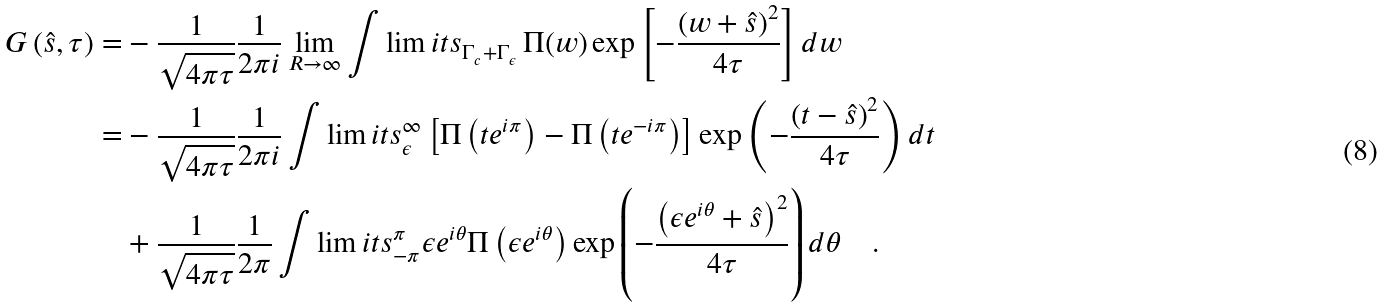Convert formula to latex. <formula><loc_0><loc_0><loc_500><loc_500>G \left ( \hat { s } , \tau \right ) = & - \frac { 1 } { \sqrt { 4 \pi \tau } } \frac { 1 } { 2 \pi i } \lim _ { R \to \infty } \int \lim i t s _ { \Gamma _ { c } + \Gamma _ { \epsilon } } \, \Pi ( w ) \exp { \left [ - \frac { \left ( w + \hat { s } \right ) ^ { 2 } } { 4 \tau } \right ] } \, d w \\ = & - \frac { 1 } { \sqrt { 4 \pi \tau } } \frac { 1 } { 2 \pi i } \int \lim i t s _ { \epsilon } ^ { \infty } \left [ \Pi \left ( t e ^ { i \pi } \right ) - \Pi \left ( t e ^ { - i \pi } \right ) \right ] \exp { \left ( - \frac { \left ( t - \hat { s } \right ) ^ { 2 } } { 4 \tau } \right ) } \, d t \\ & + \frac { 1 } { \sqrt { 4 \pi \tau } } \frac { 1 } { 2 \pi } \int \lim i t s _ { - \pi } ^ { \pi } \epsilon e ^ { i \theta } \Pi \left ( \epsilon e ^ { i \theta } \right ) \exp { \left ( - \frac { \left ( \epsilon e ^ { i \theta } + \hat { s } \right ) ^ { 2 } } { 4 \tau } \right ) } \, d \theta \quad .</formula> 